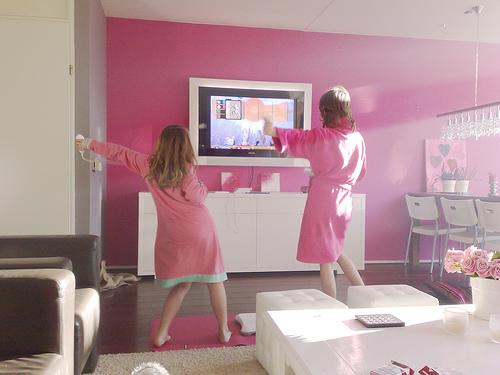What is featured by the TV? Please explain your reasoning. video game. The people are playing a wii game together and the wii is a video game console, so a video game is featured by the tv. 